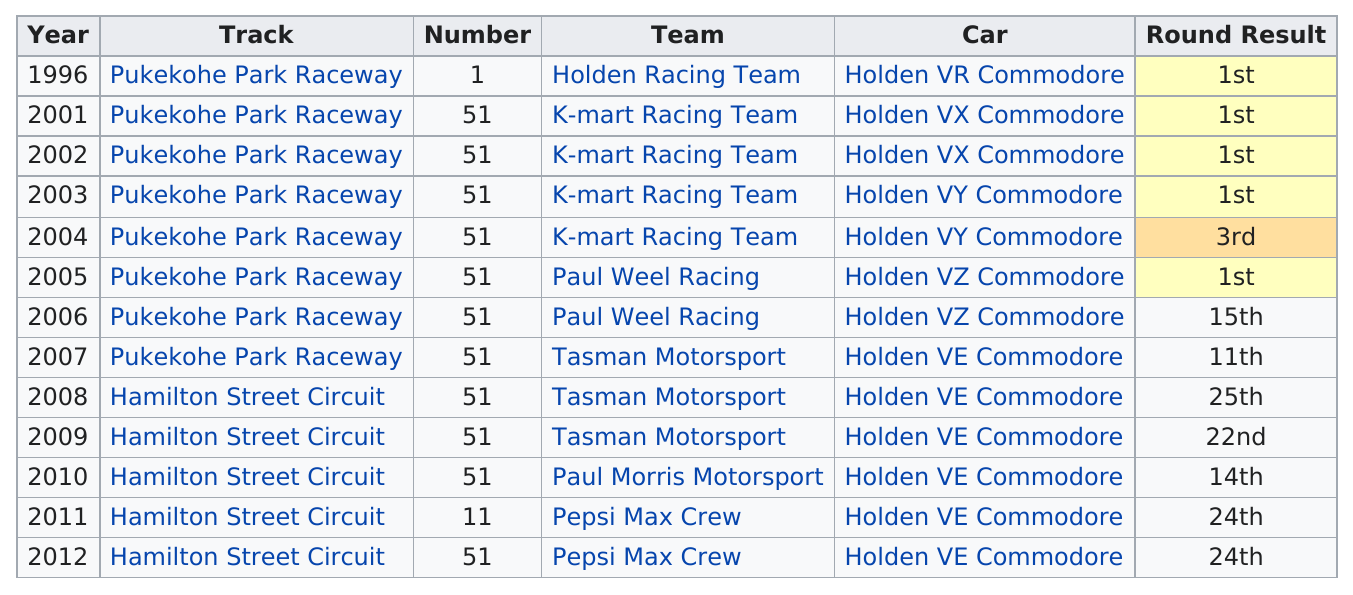Highlight a few significant elements in this photo. In the first Hamilton Street Circuit race, Greg Murphy reached a finishing position of 25th. The Holden VR Commodore was the first car that was used by Murphy in the New Zealand V8 Supercar event. The result of the round in which Holden Racing Team and Paul Weel Racing participated is that they share first place. Scott Taylor previously raced for Tasman Motorsport before joining Paul Morris Motorsport. There were a total of five 1st place results in the round. 